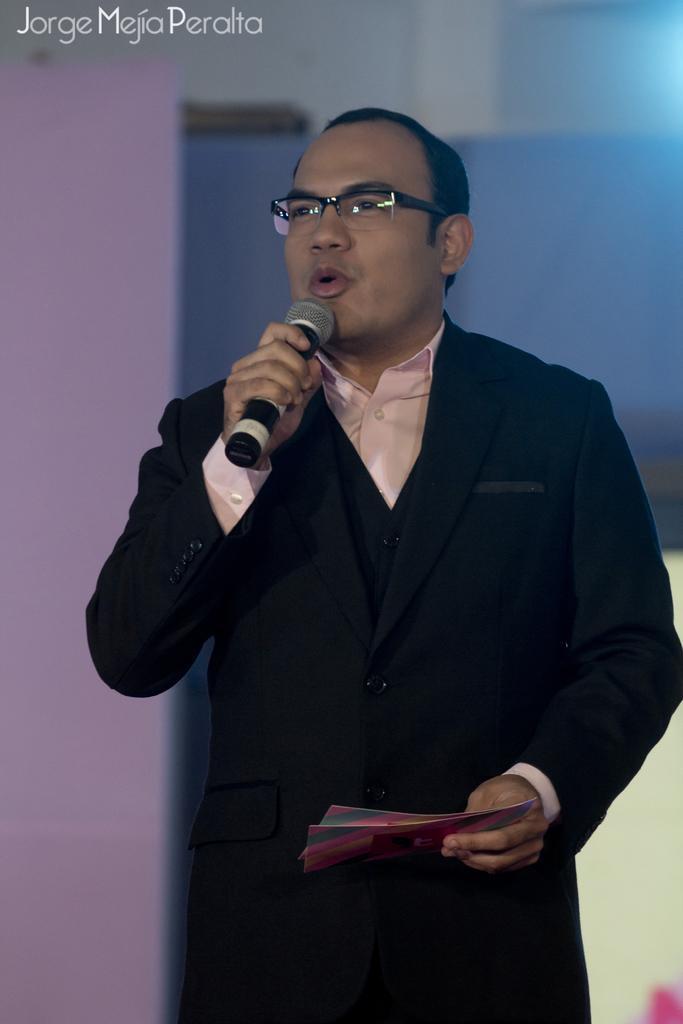Please provide a concise description of this image. This picture is mainly highlighted with a man standing and holding a mike in his hand and talking. There are few envelopes in his hand. He wore spectacles. 